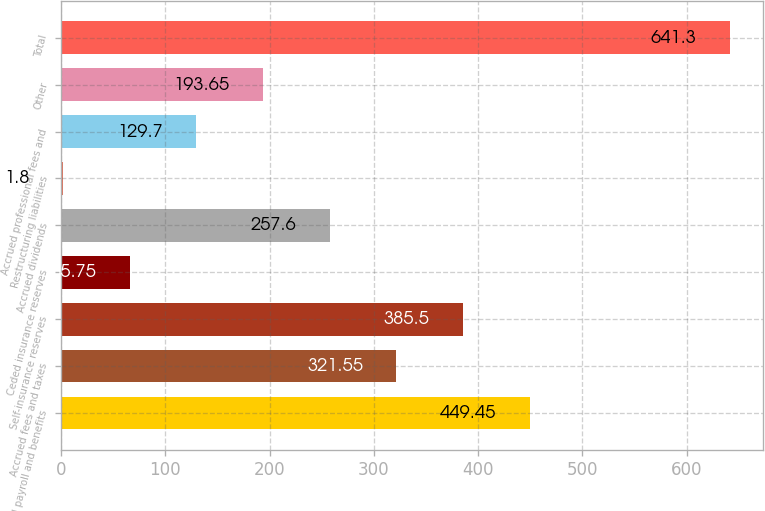Convert chart. <chart><loc_0><loc_0><loc_500><loc_500><bar_chart><fcel>Accrued payroll and benefits<fcel>Accrued fees and taxes<fcel>Self-insurance reserves<fcel>Ceded insurance reserves<fcel>Accrued dividends<fcel>Restructuring liabilities<fcel>Accrued professional fees and<fcel>Other<fcel>Total<nl><fcel>449.45<fcel>321.55<fcel>385.5<fcel>65.75<fcel>257.6<fcel>1.8<fcel>129.7<fcel>193.65<fcel>641.3<nl></chart> 